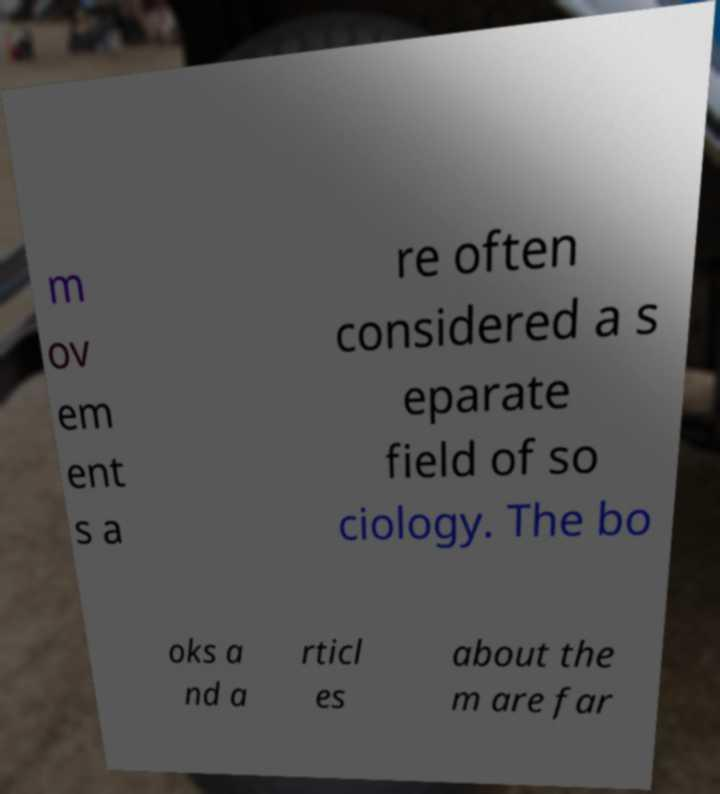Could you assist in decoding the text presented in this image and type it out clearly? m ov em ent s a re often considered a s eparate field of so ciology. The bo oks a nd a rticl es about the m are far 